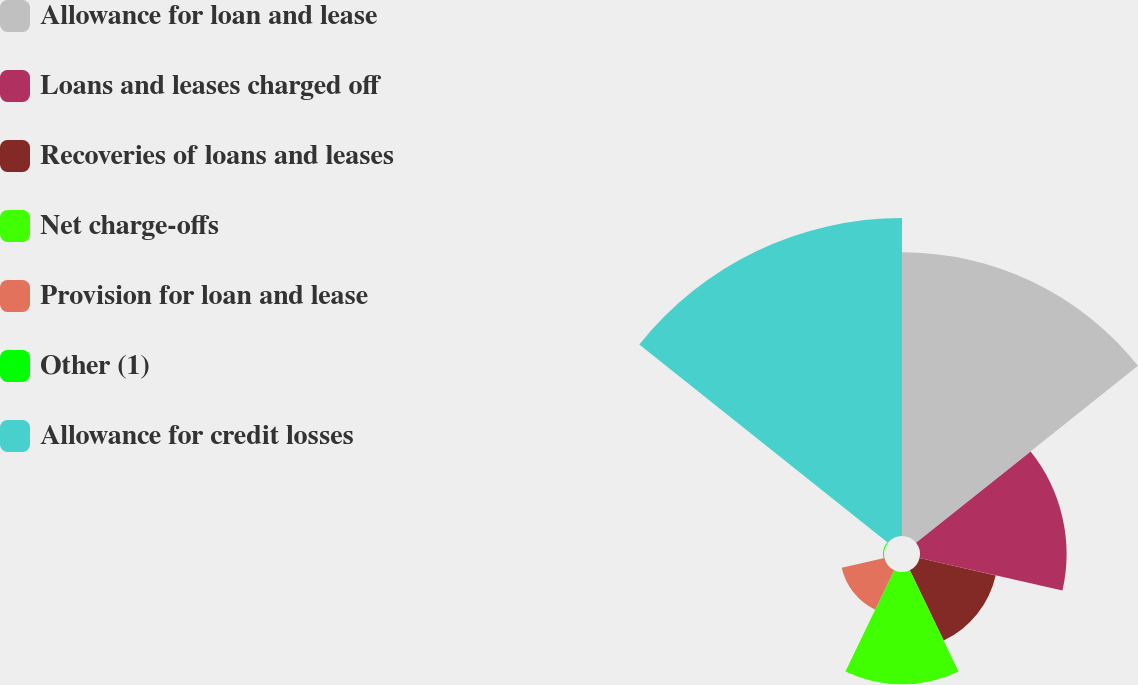<chart> <loc_0><loc_0><loc_500><loc_500><pie_chart><fcel>Allowance for loan and lease<fcel>Loans and leases charged off<fcel>Recoveries of loans and leases<fcel>Net charge-offs<fcel>Provision for loan and lease<fcel>Other (1)<fcel>Allowance for credit losses<nl><fcel>28.85%<fcel>14.9%<fcel>7.94%<fcel>11.42%<fcel>4.46%<fcel>0.09%<fcel>32.33%<nl></chart> 